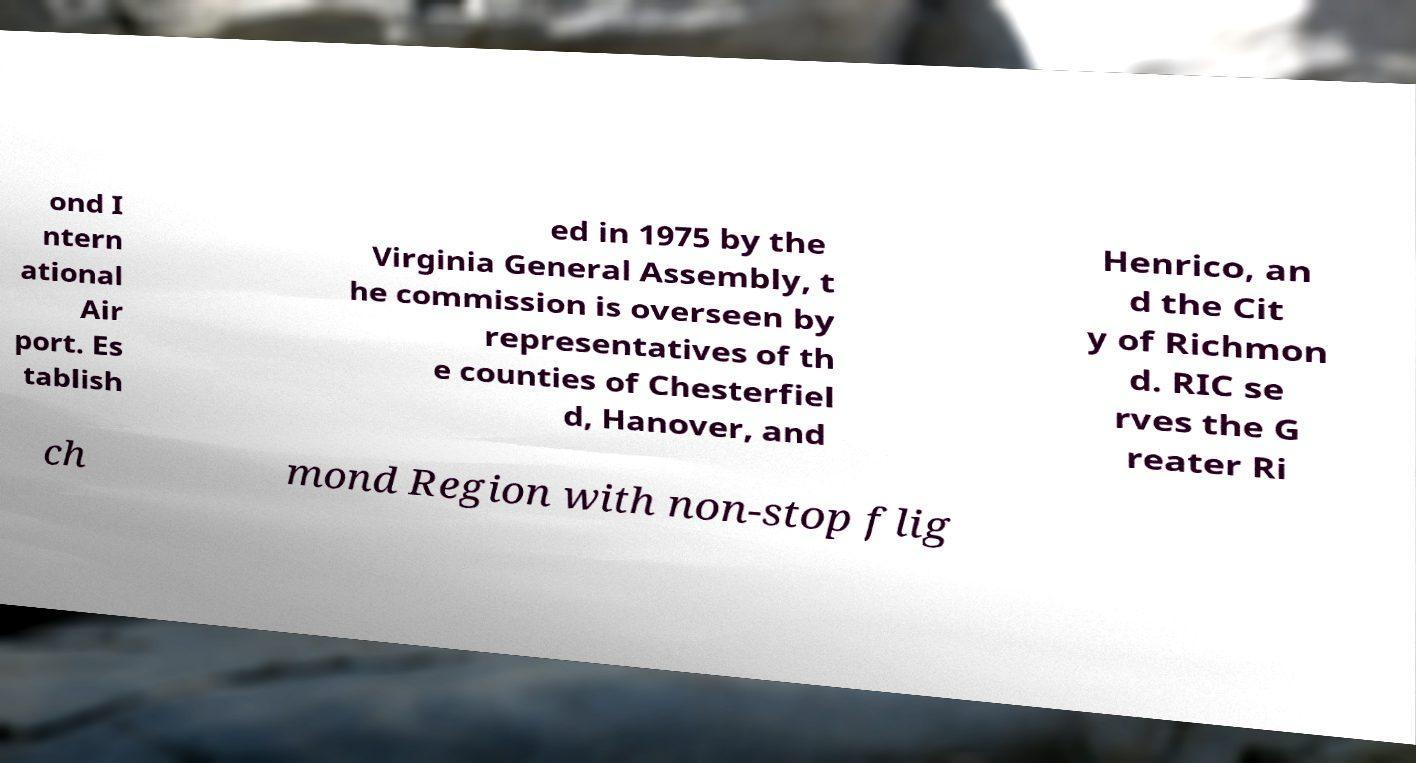What messages or text are displayed in this image? I need them in a readable, typed format. ond I ntern ational Air port. Es tablish ed in 1975 by the Virginia General Assembly, t he commission is overseen by representatives of th e counties of Chesterfiel d, Hanover, and Henrico, an d the Cit y of Richmon d. RIC se rves the G reater Ri ch mond Region with non-stop flig 